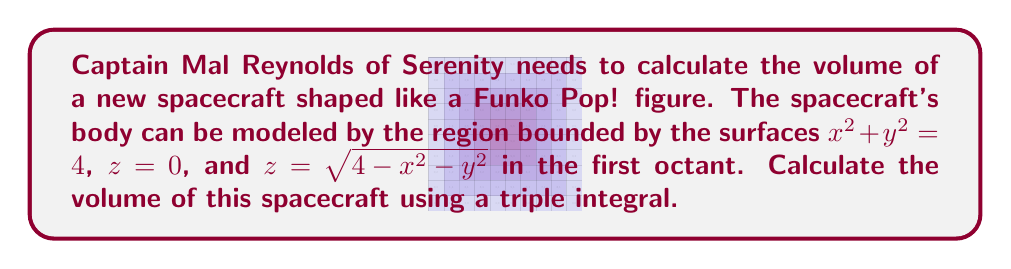Could you help me with this problem? Let's approach this step-by-step:

1) The region is bounded by a circular cylinder ($x^2 + y^2 = 4$) and a hemispherical top ($z = \sqrt{4-x^2-y^2}$) in the first octant.

2) We'll use cylindrical coordinates for this integral:
   $x = r\cos\theta$, $y = r\sin\theta$, $z = z$

3) The bounds for our integral will be:
   $0 \leq r \leq 2$ (radius of the base)
   $0 \leq \theta \leq \frac{\pi}{2}$ (first quadrant in xy-plane)
   $0 \leq z \leq \sqrt{4-r^2}$ (height from base to hemisphere)

4) The volume integral in cylindrical coordinates is:
   $$V = \int_0^{\frac{\pi}{2}} \int_0^2 \int_0^{\sqrt{4-r^2}} r \, dz \, dr \, d\theta$$

5) Let's solve the integral:
   $$V = \int_0^{\frac{\pi}{2}} \int_0^2 r \cdot \sqrt{4-r^2} \, dr \, d\theta$$

6) Integrate with respect to r:
   $$V = \int_0^{\frac{\pi}{2}} \left[-\frac{1}{3}(4-r^2)^{\frac{3}{2}}\right]_0^2 \, d\theta$$
   $$= \int_0^{\frac{\pi}{2}} \left(-\frac{1}{3}(0) + \frac{1}{3}(4)^{\frac{3}{2}}\right) \, d\theta$$
   $$= \int_0^{\frac{\pi}{2}} \frac{8}{3} \, d\theta$$

7) Finally, integrate with respect to θ:
   $$V = \frac{8}{3} \cdot \frac{\pi}{2} = \frac{4\pi}{3}$$

Therefore, the volume of the spacecraft is $\frac{4\pi}{3}$ cubic units.
Answer: $\frac{4\pi}{3}$ cubic units 